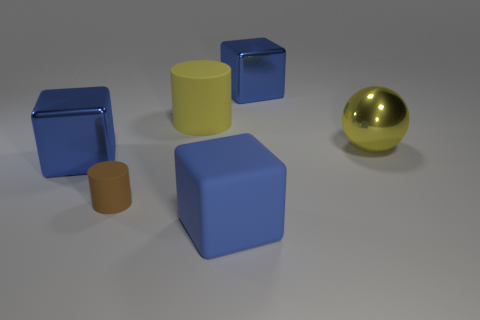Add 3 small brown objects. How many objects exist? 9 Subtract all balls. How many objects are left? 5 Add 5 tiny yellow rubber cylinders. How many tiny yellow rubber cylinders exist? 5 Subtract 0 green balls. How many objects are left? 6 Subtract all small blue metallic blocks. Subtract all big yellow matte cylinders. How many objects are left? 5 Add 2 yellow rubber objects. How many yellow rubber objects are left? 3 